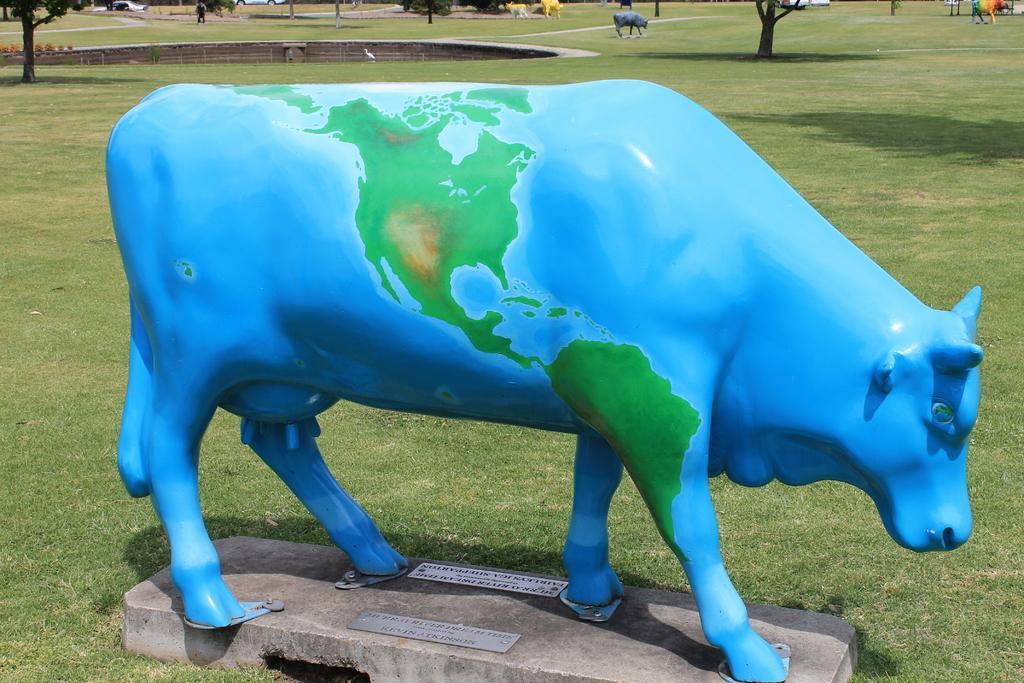Could you give a brief overview of what you see in this image? In this picture we can see a blue statue of a cow surrounded by grass and trees. 